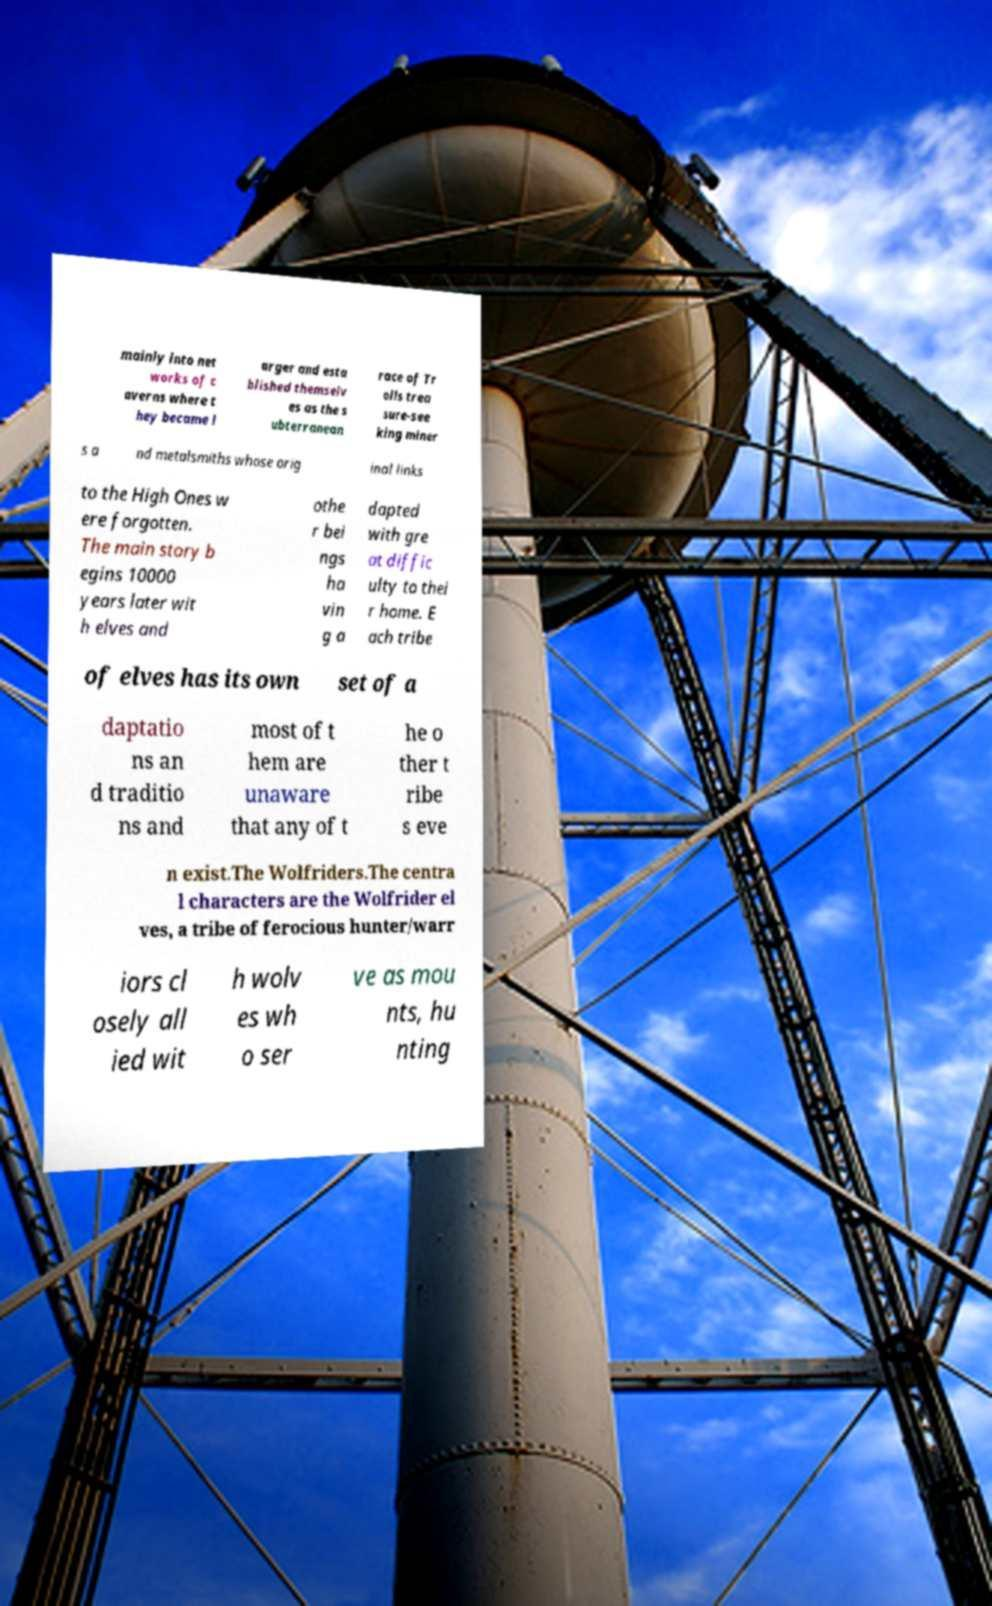There's text embedded in this image that I need extracted. Can you transcribe it verbatim? mainly into net works of c averns where t hey became l arger and esta blished themselv es as the s ubterranean race of Tr olls trea sure-see king miner s a nd metalsmiths whose orig inal links to the High Ones w ere forgotten. The main story b egins 10000 years later wit h elves and othe r bei ngs ha vin g a dapted with gre at diffic ulty to thei r home. E ach tribe of elves has its own set of a daptatio ns an d traditio ns and most of t hem are unaware that any of t he o ther t ribe s eve n exist.The Wolfriders.The centra l characters are the Wolfrider el ves, a tribe of ferocious hunter/warr iors cl osely all ied wit h wolv es wh o ser ve as mou nts, hu nting 